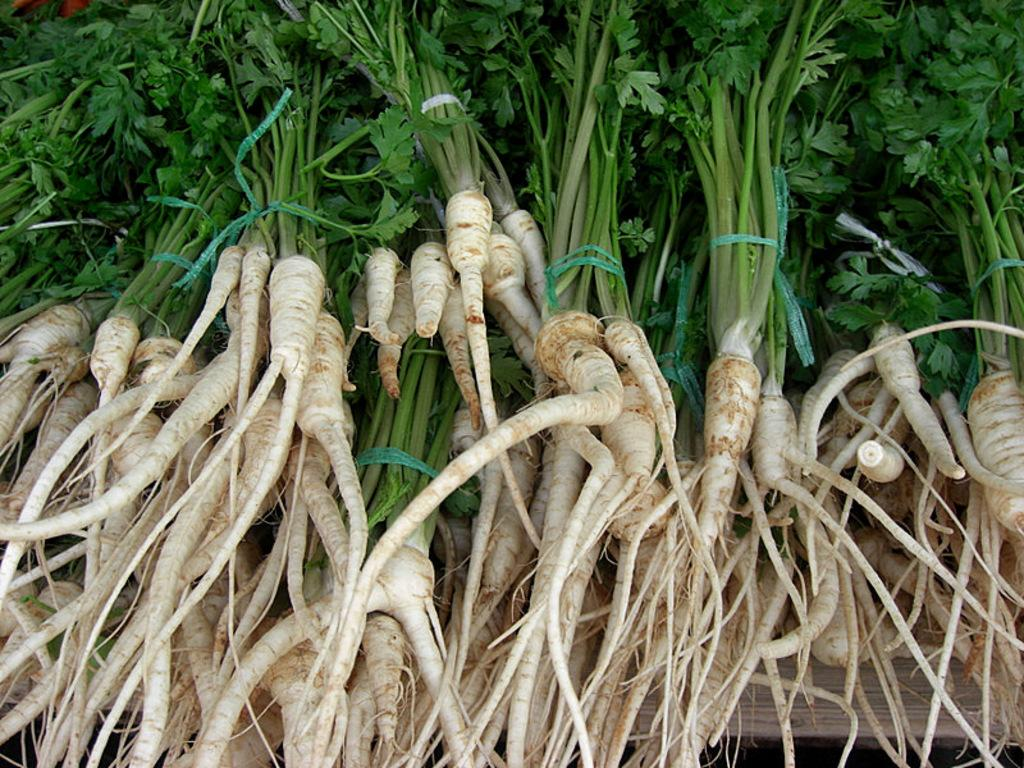What type of food is visible in the image? There are green leafy vegetables in the image. Where are the vegetables located? The vegetables are placed on a table. What can be seen attached to the roots of the vegetables? There is a white color object attached to the roots of the vegetables. How does the line of pleasure transport the vegetables in the image? There is no line of pleasure or transport present in the image; it only features green leafy vegetables on a table with a white object attached to their roots. 